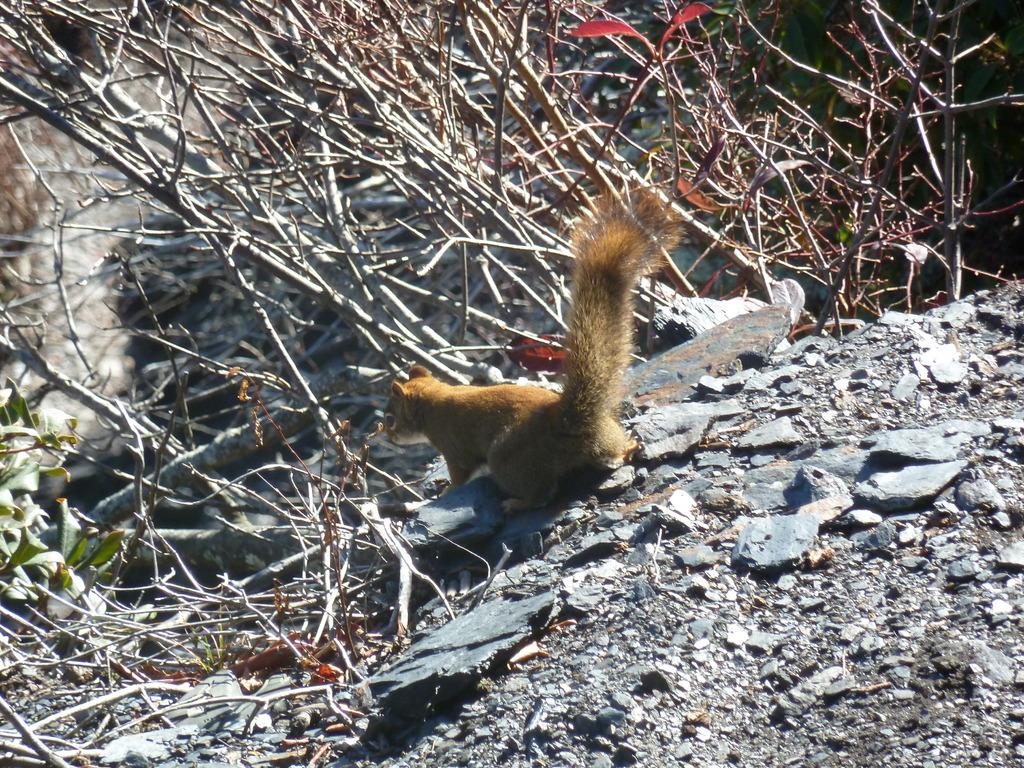Where was the picture taken? The picture was clicked outside. What is the main subject of the image? There is a squirrel in the center of the image. What is the squirrel doing in the image? The squirrel is standing on the ground. What type of terrain is visible in the image? Gravels are visible in the image. What type of vegetation is present in the image? Dry stems and green leaves are present in the image. What channel is the squirrel watching in the image? There is no television or channel present in the image; it features a squirrel standing on the ground. Who is the porter in the image? There is no porter present in the image; it features a squirrel standing on the ground. 